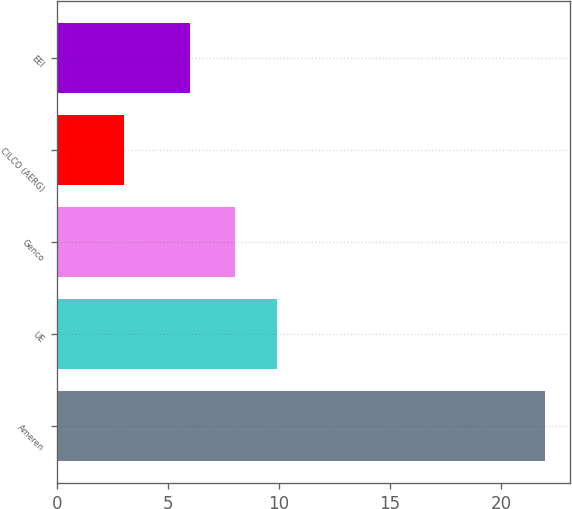<chart> <loc_0><loc_0><loc_500><loc_500><bar_chart><fcel>Ameren<fcel>UE<fcel>Genco<fcel>CILCO (AERG)<fcel>EEI<nl><fcel>22<fcel>9.9<fcel>8<fcel>3<fcel>6<nl></chart> 